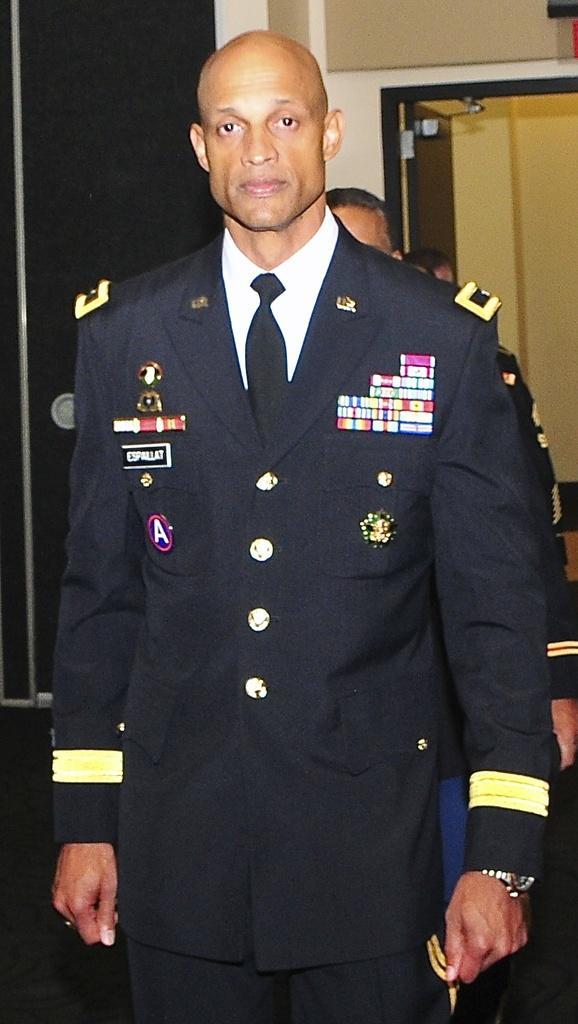Can you describe this image briefly? In this image, there are a few people. We can see the wall with some objects. We can also see a black colored object. 